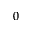Convert formula to latex. <formula><loc_0><loc_0><loc_500><loc_500>0</formula> 